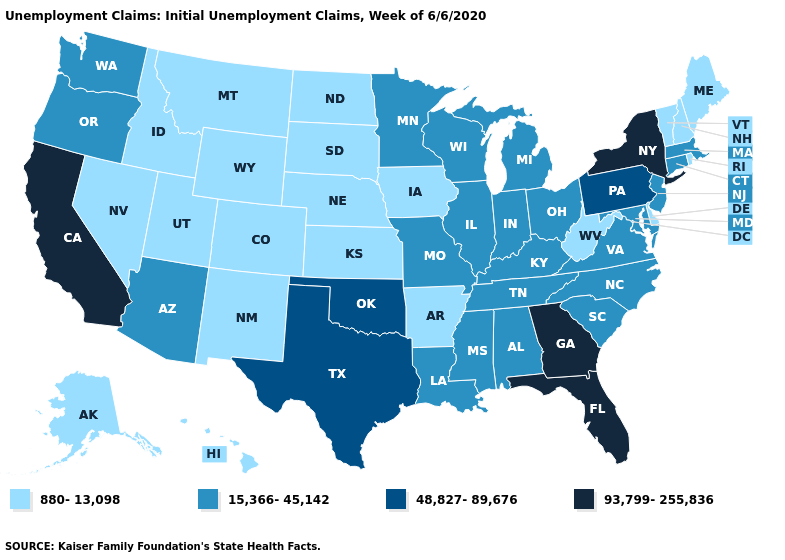What is the value of Virginia?
Concise answer only. 15,366-45,142. What is the highest value in states that border Arizona?
Short answer required. 93,799-255,836. Which states have the lowest value in the Northeast?
Keep it brief. Maine, New Hampshire, Rhode Island, Vermont. What is the value of Iowa?
Keep it brief. 880-13,098. What is the value of Kansas?
Answer briefly. 880-13,098. Which states hav the highest value in the South?
Keep it brief. Florida, Georgia. Does the map have missing data?
Answer briefly. No. Name the states that have a value in the range 48,827-89,676?
Quick response, please. Oklahoma, Pennsylvania, Texas. What is the value of Rhode Island?
Concise answer only. 880-13,098. Which states have the highest value in the USA?
Answer briefly. California, Florida, Georgia, New York. What is the value of New York?
Quick response, please. 93,799-255,836. What is the value of Wisconsin?
Write a very short answer. 15,366-45,142. Name the states that have a value in the range 880-13,098?
Keep it brief. Alaska, Arkansas, Colorado, Delaware, Hawaii, Idaho, Iowa, Kansas, Maine, Montana, Nebraska, Nevada, New Hampshire, New Mexico, North Dakota, Rhode Island, South Dakota, Utah, Vermont, West Virginia, Wyoming. Does California have the highest value in the West?
Give a very brief answer. Yes. What is the highest value in the USA?
Short answer required. 93,799-255,836. 